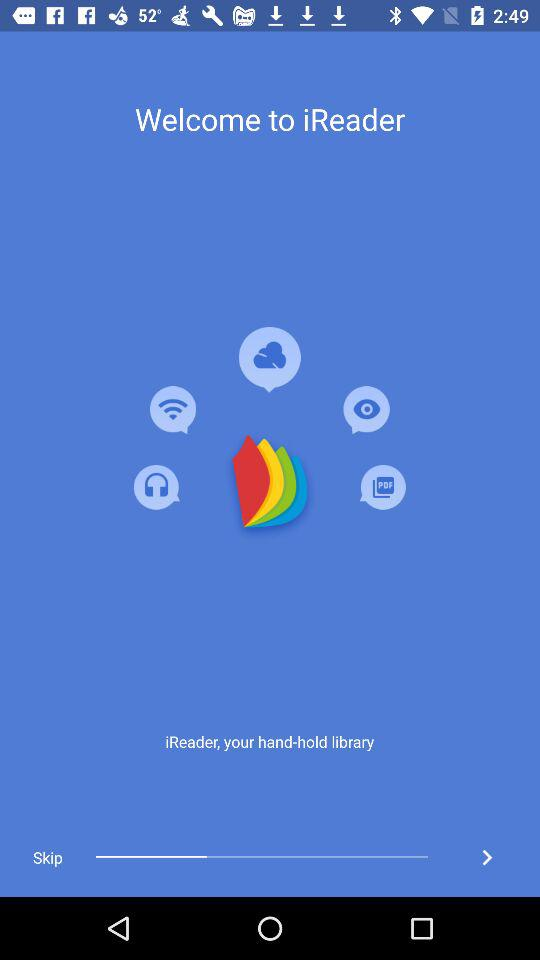What is the application name? The application name is "iReader". 